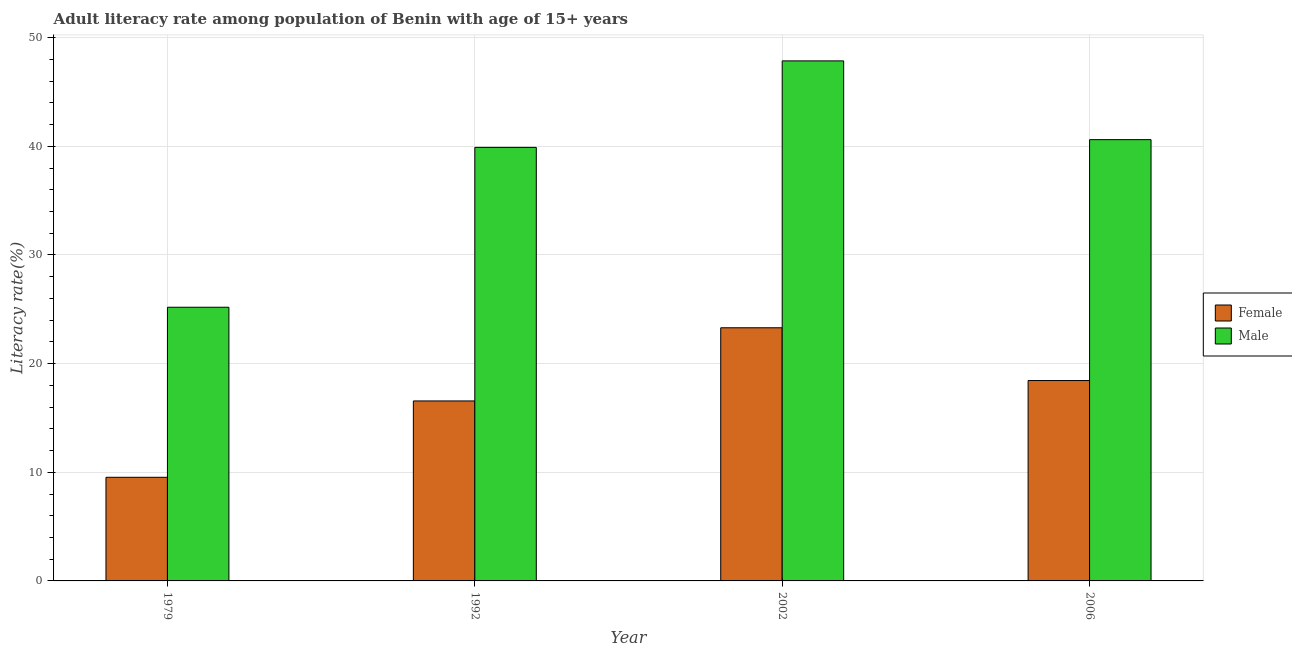How many groups of bars are there?
Your response must be concise. 4. Are the number of bars per tick equal to the number of legend labels?
Your response must be concise. Yes. Are the number of bars on each tick of the X-axis equal?
Offer a very short reply. Yes. How many bars are there on the 4th tick from the left?
Make the answer very short. 2. How many bars are there on the 2nd tick from the right?
Provide a succinct answer. 2. What is the label of the 4th group of bars from the left?
Make the answer very short. 2006. In how many cases, is the number of bars for a given year not equal to the number of legend labels?
Your response must be concise. 0. What is the male adult literacy rate in 2006?
Provide a short and direct response. 40.62. Across all years, what is the maximum male adult literacy rate?
Your answer should be very brief. 47.87. Across all years, what is the minimum female adult literacy rate?
Make the answer very short. 9.54. In which year was the female adult literacy rate maximum?
Your answer should be compact. 2002. In which year was the male adult literacy rate minimum?
Your answer should be very brief. 1979. What is the total female adult literacy rate in the graph?
Give a very brief answer. 67.85. What is the difference between the female adult literacy rate in 1979 and that in 1992?
Offer a terse response. -7.03. What is the difference between the male adult literacy rate in 2006 and the female adult literacy rate in 2002?
Provide a succinct answer. -7.25. What is the average female adult literacy rate per year?
Ensure brevity in your answer.  16.96. In how many years, is the female adult literacy rate greater than 4 %?
Provide a short and direct response. 4. What is the ratio of the male adult literacy rate in 1992 to that in 2006?
Give a very brief answer. 0.98. Is the female adult literacy rate in 1979 less than that in 2006?
Provide a short and direct response. Yes. Is the difference between the male adult literacy rate in 2002 and 2006 greater than the difference between the female adult literacy rate in 2002 and 2006?
Offer a terse response. No. What is the difference between the highest and the second highest male adult literacy rate?
Your answer should be very brief. 7.25. What is the difference between the highest and the lowest male adult literacy rate?
Keep it short and to the point. 22.68. In how many years, is the female adult literacy rate greater than the average female adult literacy rate taken over all years?
Make the answer very short. 2. What does the 1st bar from the right in 1992 represents?
Ensure brevity in your answer.  Male. How many years are there in the graph?
Provide a succinct answer. 4. Does the graph contain any zero values?
Offer a very short reply. No. What is the title of the graph?
Make the answer very short. Adult literacy rate among population of Benin with age of 15+ years. What is the label or title of the Y-axis?
Offer a terse response. Literacy rate(%). What is the Literacy rate(%) in Female in 1979?
Provide a short and direct response. 9.54. What is the Literacy rate(%) of Male in 1979?
Your answer should be compact. 25.19. What is the Literacy rate(%) in Female in 1992?
Offer a very short reply. 16.57. What is the Literacy rate(%) in Male in 1992?
Ensure brevity in your answer.  39.9. What is the Literacy rate(%) of Female in 2002?
Give a very brief answer. 23.3. What is the Literacy rate(%) of Male in 2002?
Your response must be concise. 47.87. What is the Literacy rate(%) in Female in 2006?
Make the answer very short. 18.44. What is the Literacy rate(%) of Male in 2006?
Keep it short and to the point. 40.62. Across all years, what is the maximum Literacy rate(%) of Female?
Ensure brevity in your answer.  23.3. Across all years, what is the maximum Literacy rate(%) of Male?
Your response must be concise. 47.87. Across all years, what is the minimum Literacy rate(%) in Female?
Make the answer very short. 9.54. Across all years, what is the minimum Literacy rate(%) of Male?
Provide a short and direct response. 25.19. What is the total Literacy rate(%) in Female in the graph?
Your answer should be compact. 67.85. What is the total Literacy rate(%) in Male in the graph?
Ensure brevity in your answer.  153.58. What is the difference between the Literacy rate(%) of Female in 1979 and that in 1992?
Make the answer very short. -7.03. What is the difference between the Literacy rate(%) of Male in 1979 and that in 1992?
Your response must be concise. -14.71. What is the difference between the Literacy rate(%) in Female in 1979 and that in 2002?
Provide a succinct answer. -13.76. What is the difference between the Literacy rate(%) of Male in 1979 and that in 2002?
Your response must be concise. -22.68. What is the difference between the Literacy rate(%) in Female in 1979 and that in 2006?
Offer a terse response. -8.9. What is the difference between the Literacy rate(%) in Male in 1979 and that in 2006?
Offer a very short reply. -15.43. What is the difference between the Literacy rate(%) in Female in 1992 and that in 2002?
Ensure brevity in your answer.  -6.73. What is the difference between the Literacy rate(%) in Male in 1992 and that in 2002?
Offer a terse response. -7.96. What is the difference between the Literacy rate(%) of Female in 1992 and that in 2006?
Offer a very short reply. -1.88. What is the difference between the Literacy rate(%) of Male in 1992 and that in 2006?
Provide a short and direct response. -0.71. What is the difference between the Literacy rate(%) in Female in 2002 and that in 2006?
Provide a short and direct response. 4.86. What is the difference between the Literacy rate(%) of Male in 2002 and that in 2006?
Provide a succinct answer. 7.25. What is the difference between the Literacy rate(%) of Female in 1979 and the Literacy rate(%) of Male in 1992?
Make the answer very short. -30.36. What is the difference between the Literacy rate(%) in Female in 1979 and the Literacy rate(%) in Male in 2002?
Give a very brief answer. -38.33. What is the difference between the Literacy rate(%) of Female in 1979 and the Literacy rate(%) of Male in 2006?
Your answer should be compact. -31.08. What is the difference between the Literacy rate(%) in Female in 1992 and the Literacy rate(%) in Male in 2002?
Give a very brief answer. -31.3. What is the difference between the Literacy rate(%) of Female in 1992 and the Literacy rate(%) of Male in 2006?
Ensure brevity in your answer.  -24.05. What is the difference between the Literacy rate(%) of Female in 2002 and the Literacy rate(%) of Male in 2006?
Provide a short and direct response. -17.32. What is the average Literacy rate(%) in Female per year?
Your response must be concise. 16.96. What is the average Literacy rate(%) of Male per year?
Provide a succinct answer. 38.39. In the year 1979, what is the difference between the Literacy rate(%) in Female and Literacy rate(%) in Male?
Provide a succinct answer. -15.65. In the year 1992, what is the difference between the Literacy rate(%) of Female and Literacy rate(%) of Male?
Your answer should be very brief. -23.34. In the year 2002, what is the difference between the Literacy rate(%) in Female and Literacy rate(%) in Male?
Offer a terse response. -24.57. In the year 2006, what is the difference between the Literacy rate(%) in Female and Literacy rate(%) in Male?
Provide a short and direct response. -22.17. What is the ratio of the Literacy rate(%) of Female in 1979 to that in 1992?
Your response must be concise. 0.58. What is the ratio of the Literacy rate(%) in Male in 1979 to that in 1992?
Your answer should be very brief. 0.63. What is the ratio of the Literacy rate(%) of Female in 1979 to that in 2002?
Offer a very short reply. 0.41. What is the ratio of the Literacy rate(%) of Male in 1979 to that in 2002?
Your response must be concise. 0.53. What is the ratio of the Literacy rate(%) in Female in 1979 to that in 2006?
Your answer should be very brief. 0.52. What is the ratio of the Literacy rate(%) of Male in 1979 to that in 2006?
Provide a short and direct response. 0.62. What is the ratio of the Literacy rate(%) in Female in 1992 to that in 2002?
Keep it short and to the point. 0.71. What is the ratio of the Literacy rate(%) in Male in 1992 to that in 2002?
Your answer should be very brief. 0.83. What is the ratio of the Literacy rate(%) of Female in 1992 to that in 2006?
Offer a very short reply. 0.9. What is the ratio of the Literacy rate(%) in Male in 1992 to that in 2006?
Give a very brief answer. 0.98. What is the ratio of the Literacy rate(%) in Female in 2002 to that in 2006?
Provide a succinct answer. 1.26. What is the ratio of the Literacy rate(%) of Male in 2002 to that in 2006?
Offer a terse response. 1.18. What is the difference between the highest and the second highest Literacy rate(%) of Female?
Your response must be concise. 4.86. What is the difference between the highest and the second highest Literacy rate(%) in Male?
Provide a short and direct response. 7.25. What is the difference between the highest and the lowest Literacy rate(%) of Female?
Your answer should be compact. 13.76. What is the difference between the highest and the lowest Literacy rate(%) of Male?
Provide a short and direct response. 22.68. 